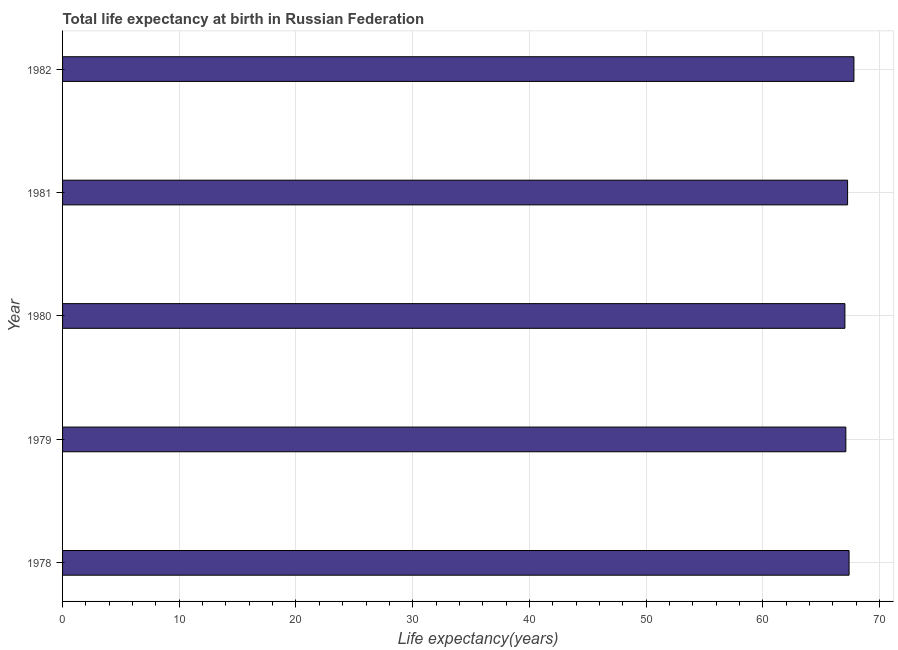Does the graph contain any zero values?
Give a very brief answer. No. What is the title of the graph?
Give a very brief answer. Total life expectancy at birth in Russian Federation. What is the label or title of the X-axis?
Your answer should be very brief. Life expectancy(years). What is the life expectancy at birth in 1979?
Your answer should be compact. 67.11. Across all years, what is the maximum life expectancy at birth?
Your response must be concise. 67.81. Across all years, what is the minimum life expectancy at birth?
Offer a terse response. 67.03. What is the sum of the life expectancy at birth?
Provide a short and direct response. 336.61. What is the difference between the life expectancy at birth in 1979 and 1982?
Make the answer very short. -0.69. What is the average life expectancy at birth per year?
Offer a terse response. 67.32. What is the median life expectancy at birth?
Offer a very short reply. 67.26. Is the life expectancy at birth in 1978 less than that in 1979?
Provide a succinct answer. No. Is the difference between the life expectancy at birth in 1980 and 1982 greater than the difference between any two years?
Offer a terse response. Yes. What is the difference between the highest and the second highest life expectancy at birth?
Offer a terse response. 0.41. What is the difference between the highest and the lowest life expectancy at birth?
Offer a very short reply. 0.77. Are the values on the major ticks of X-axis written in scientific E-notation?
Provide a succinct answer. No. What is the Life expectancy(years) in 1978?
Your response must be concise. 67.39. What is the Life expectancy(years) in 1979?
Your answer should be compact. 67.11. What is the Life expectancy(years) in 1980?
Your answer should be compact. 67.03. What is the Life expectancy(years) in 1981?
Offer a terse response. 67.26. What is the Life expectancy(years) of 1982?
Keep it short and to the point. 67.81. What is the difference between the Life expectancy(years) in 1978 and 1979?
Your response must be concise. 0.28. What is the difference between the Life expectancy(years) in 1978 and 1980?
Provide a succinct answer. 0.36. What is the difference between the Life expectancy(years) in 1978 and 1981?
Your response must be concise. 0.13. What is the difference between the Life expectancy(years) in 1978 and 1982?
Your response must be concise. -0.42. What is the difference between the Life expectancy(years) in 1979 and 1980?
Keep it short and to the point. 0.08. What is the difference between the Life expectancy(years) in 1979 and 1981?
Give a very brief answer. -0.15. What is the difference between the Life expectancy(years) in 1979 and 1982?
Your answer should be very brief. -0.69. What is the difference between the Life expectancy(years) in 1980 and 1981?
Make the answer very short. -0.23. What is the difference between the Life expectancy(years) in 1980 and 1982?
Your answer should be very brief. -0.77. What is the difference between the Life expectancy(years) in 1981 and 1982?
Ensure brevity in your answer.  -0.54. What is the ratio of the Life expectancy(years) in 1978 to that in 1982?
Offer a terse response. 0.99. What is the ratio of the Life expectancy(years) in 1979 to that in 1981?
Your answer should be very brief. 1. What is the ratio of the Life expectancy(years) in 1979 to that in 1982?
Give a very brief answer. 0.99. What is the ratio of the Life expectancy(years) in 1980 to that in 1981?
Your answer should be very brief. 1. What is the ratio of the Life expectancy(years) in 1980 to that in 1982?
Provide a succinct answer. 0.99. 